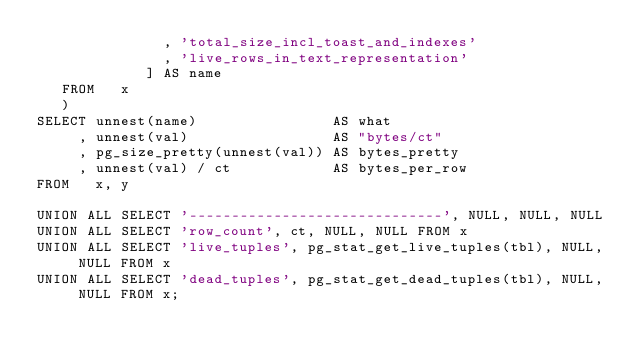Convert code to text. <code><loc_0><loc_0><loc_500><loc_500><_SQL_>               , 'total_size_incl_toast_and_indexes'
               , 'live_rows_in_text_representation'
             ] AS name
   FROM   x
   )
SELECT unnest(name)                AS what
     , unnest(val)                 AS "bytes/ct"
     , pg_size_pretty(unnest(val)) AS bytes_pretty
     , unnest(val) / ct            AS bytes_per_row
FROM   x, y

UNION ALL SELECT '------------------------------', NULL, NULL, NULL
UNION ALL SELECT 'row_count', ct, NULL, NULL FROM x
UNION ALL SELECT 'live_tuples', pg_stat_get_live_tuples(tbl), NULL, NULL FROM x
UNION ALL SELECT 'dead_tuples', pg_stat_get_dead_tuples(tbl), NULL, NULL FROM x;
</code> 